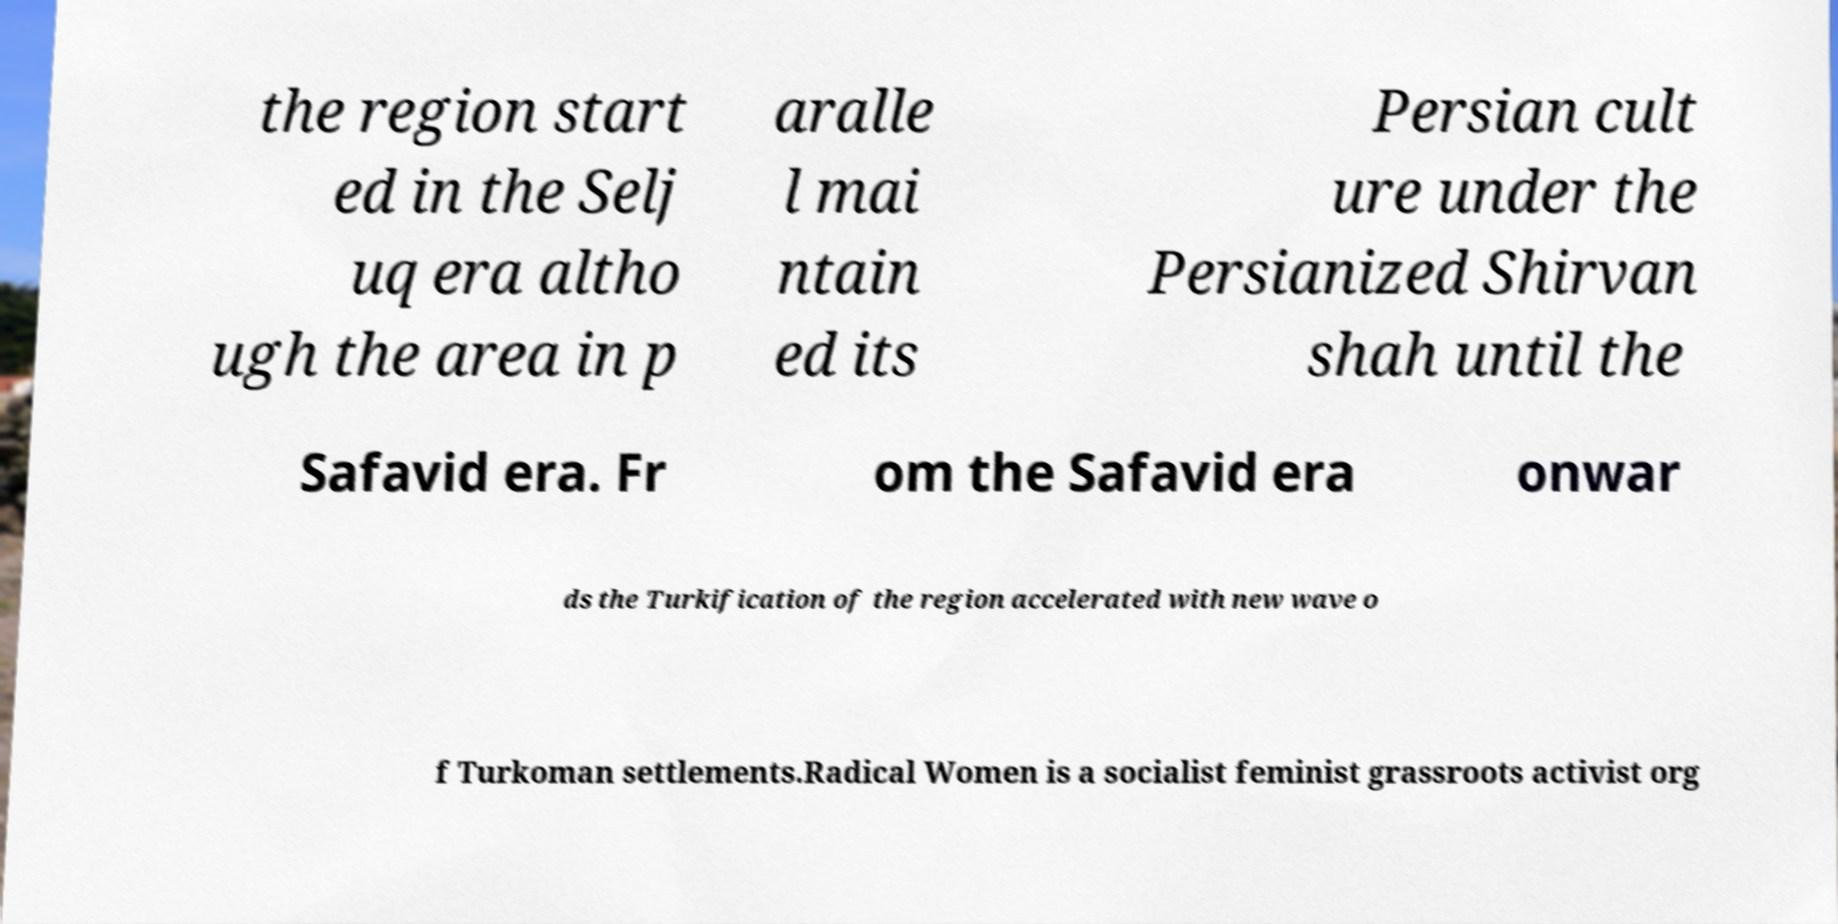I need the written content from this picture converted into text. Can you do that? the region start ed in the Selj uq era altho ugh the area in p aralle l mai ntain ed its Persian cult ure under the Persianized Shirvan shah until the Safavid era. Fr om the Safavid era onwar ds the Turkification of the region accelerated with new wave o f Turkoman settlements.Radical Women is a socialist feminist grassroots activist org 